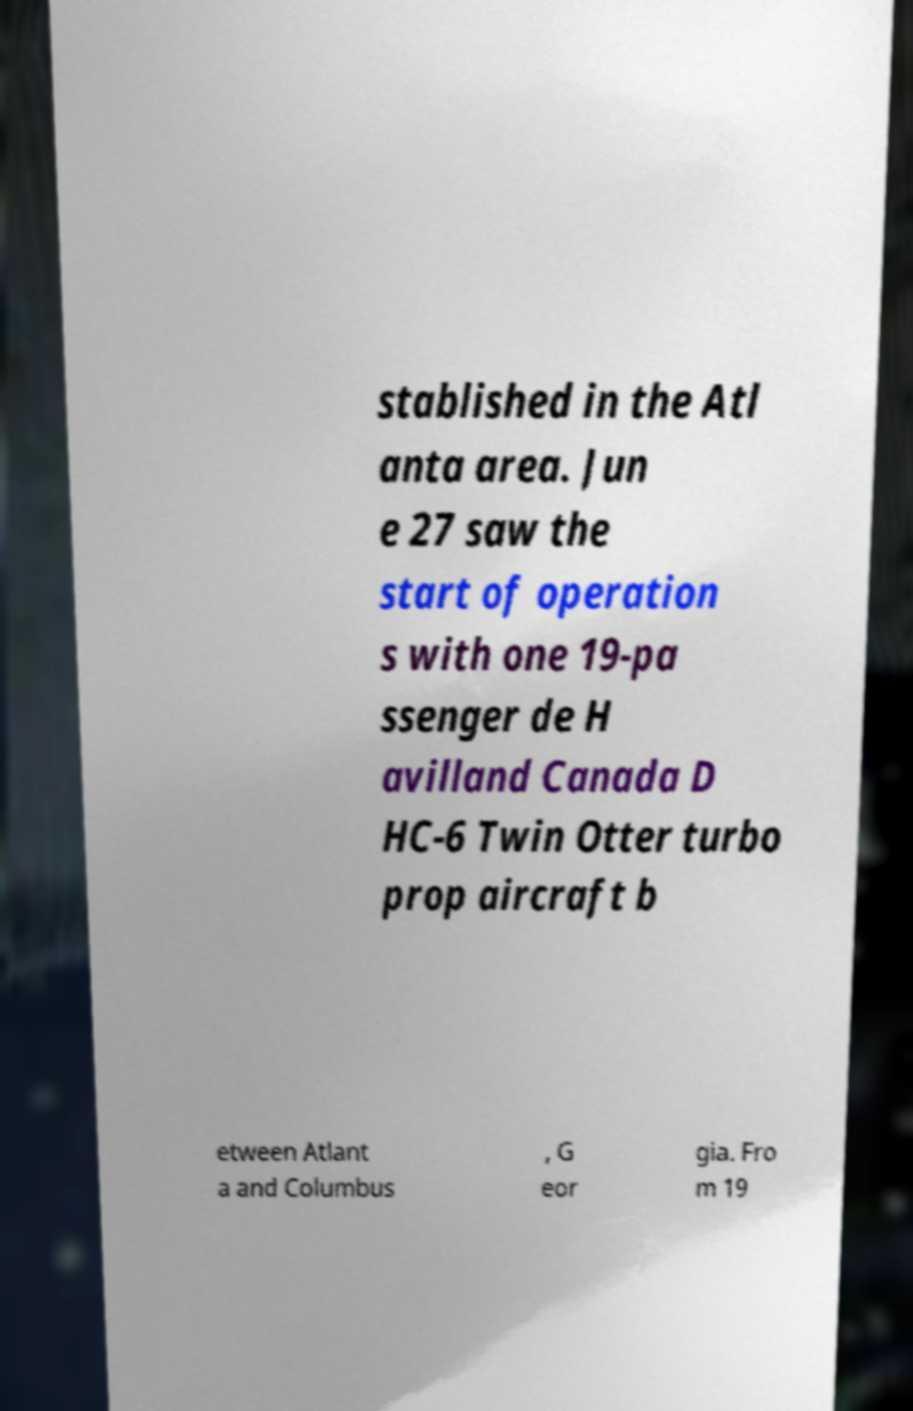There's text embedded in this image that I need extracted. Can you transcribe it verbatim? stablished in the Atl anta area. Jun e 27 saw the start of operation s with one 19-pa ssenger de H avilland Canada D HC-6 Twin Otter turbo prop aircraft b etween Atlant a and Columbus , G eor gia. Fro m 19 